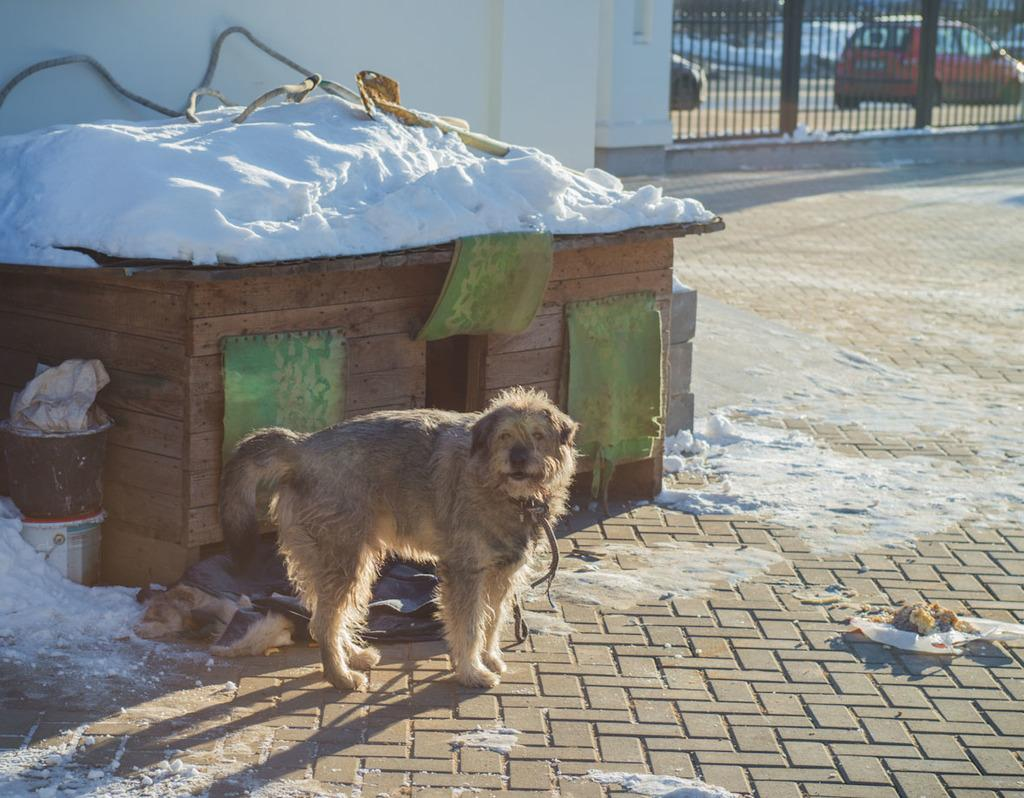What type of animal can be seen in the image? There is a dog in the image. What objects are on the ground in the image? There are buckets on the ground in the image. What is the weather like in the image? There is snow visible in the image, indicating a cold or wintery environment. What can be seen in the background of the image? There is a wall in the background of the image, and fancy cars are present on the road. What type of poison is the dog consuming in the image? There is no indication in the image that the dog is consuming any poison. What type of connection is the dog making with the wall in the image? The dog is not making any connection with the wall in the image; it is simply present in the scene. 